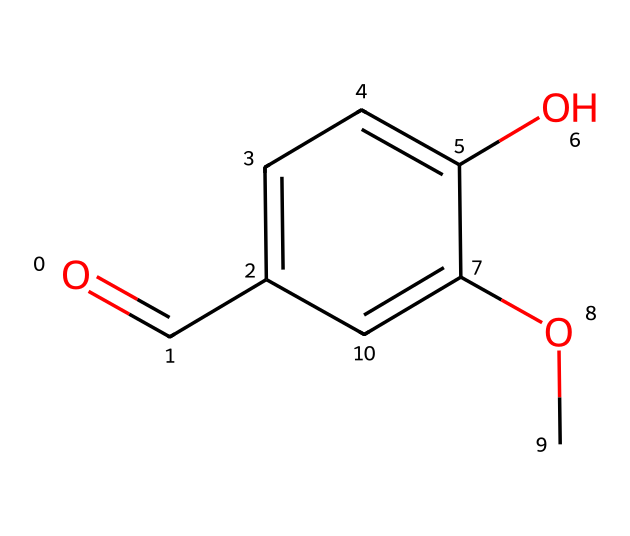What is the formula of vanillin? The formula can be derived from the SMILES representation by identifying the elements and their quantities: O (oxygen) appears twice, C (carbon) appears eight times, and H (hydrogen) appears eight times. Combining these gives the chemical formula C8H8O3.
Answer: C8H8O3 How many hydroxyl (-OH) groups does vanillin contain? By examining the structure, we can see that there is one hydroxyl (-OH) group attached to the aromatic ring, which is represented in the chemical structure. This accounts for one hydroxyl group.
Answer: one What type of functional group is primarily responsible for vanillin's flavor? The structure includes a formyl group (-CHO), which is a characteristic functional group associated with flavor compounds. This functional group contributes to the overall flavor profile of vanillin.
Answer: formyl group How many carbon atoms are in vanillin? Looking at the SMILES representation, we can count the number of carbon (C) atoms indicated. There are a total of eight carbon atoms in the structure.
Answer: eight What is the primary use of vanillin in cocktails? Vanillin is commonly used as a flavoring agent in cocktails, providing a sweet and aromatic taste reminiscent of vanilla. This characteristic makes it a favorite in vanilla-based cocktails.
Answer: flavoring agent Does vanillin contain any double bonds? By closely examining the structure, we can identify the presence of double bonds between carbon and oxygen atoms (in the carbonyl and ether groups), confirming that this compound has double bonds.
Answer: yes What characteristic scent does vanillin provide to cocktails?$ Vanillin contributes a sweet, creamy, and warm scent resembling vanilla, which enhances the aroma of cocktails and is particularly appealing in vanilla-flavored drinks.
Answer: vanilla scent 